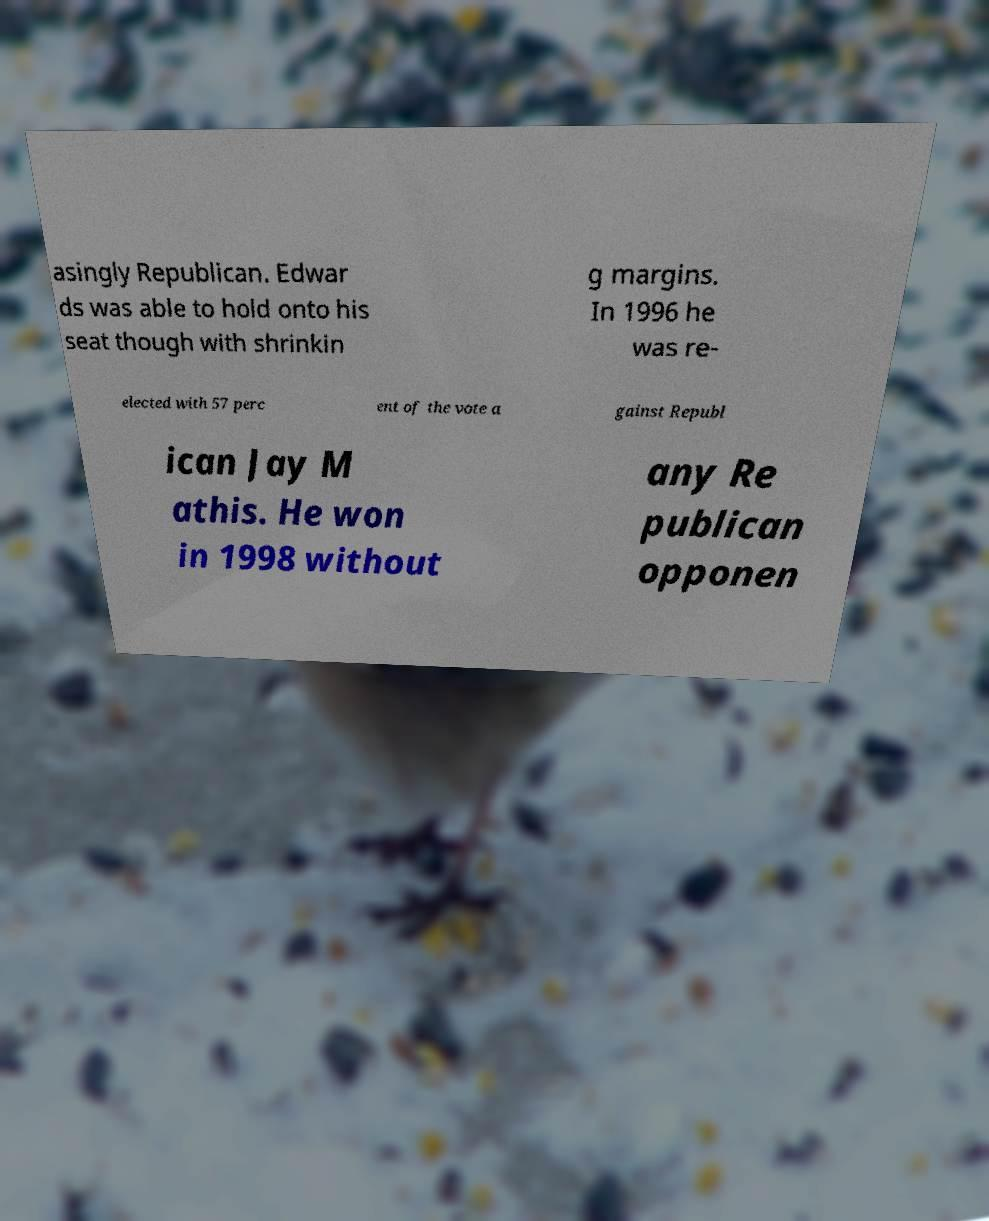Please read and relay the text visible in this image. What does it say? asingly Republican. Edwar ds was able to hold onto his seat though with shrinkin g margins. In 1996 he was re- elected with 57 perc ent of the vote a gainst Republ ican Jay M athis. He won in 1998 without any Re publican opponen 